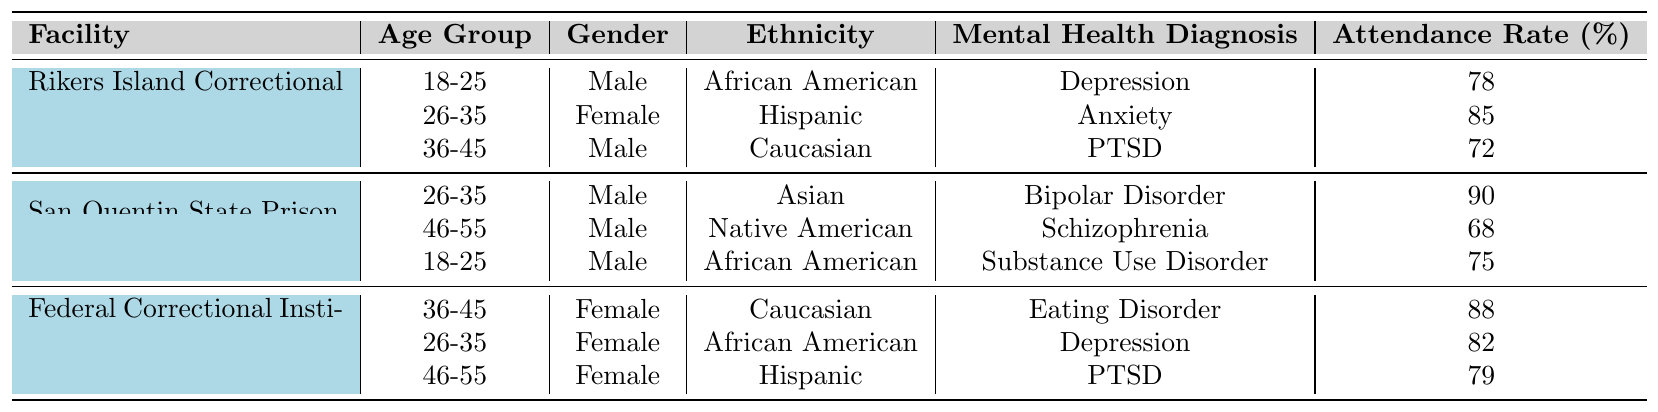What is the attendance rate for participants aged 18-25 at Rikers Island? The attendance rate for the age group 18-25 at Rikers Island Correctional Center is given as 78%.
Answer: 78% Which facility has the highest attendance rate for the 26-35 age group? At San Quentin State Prison, the attendance rate for the 26-35 age group is 90%, which is higher than any other facility's rate for that age group.
Answer: San Quentin State Prison What is the average attendance rate across all participants in Rikers Island? The attendance rates for Rikers Island are 78, 85, and 72. The sum is 78 + 85 + 72 = 235. The average is 235 / 3 = 78.33.
Answer: 78.33% Does any participant identify as Female in San Quentin State Prison? In San Quentin State Prison, all participants listed are Male, so there are no Female participants.
Answer: No What percentage of participants aged 46-55 across all facilities have an attendance rate below 80%? At San Quentin, the attendance rate for 46-55 is 68% (below 80%). At Danbury, the attendance rate is 79% (not below 80%). Therefore, only 1 of the 2 participants in this age group has an attendance rate below 80%, which is 50%.
Answer: 50% Which ethnic group had the lowest attendance rate in the provided facilities? The lowest attendance rate is 68%, which belongs to the Native American participant at San Quentin State Prison.
Answer: Native American How many participants have a mental health diagnosis of PTSD? There are two participants with a PTSD diagnosis: one from Rikers Island and one from Danbury.
Answer: 2 What is the total number of participants in the table? There are three participants from Rikers Island, three from San Quentin, and three from Danbury, adding up to 9 participants in total.
Answer: 9 Is there any Female participant in the 36-45 age group across all facilities? Yes, there is one Female participant aged 36-45 from the Federal Correctional Institution, Danbury, with an attendance rate of 88%.
Answer: Yes What is the difference in attendance rates between the highest and lowest participant at Rikers Island? The highest rate at Rikers Island is 85% (26-35 age group), and the lowest is 72% (36-45 age group). The difference is 85 - 72 = 13%.
Answer: 13% At which facility do participants have, on average, an attendance rate of over 80%? For Rikers Island, the average is 78.33%, for San Quentin, it is 77.67%, and for Danbury, it is 82.33%. Only Danbury has an average above 80%.
Answer: Federal Correctional Institution, Danbury 